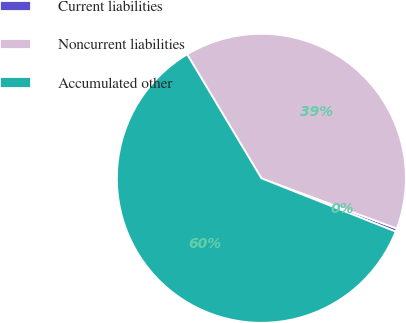Convert chart. <chart><loc_0><loc_0><loc_500><loc_500><pie_chart><fcel>Current liabilities<fcel>Noncurrent liabilities<fcel>Accumulated other<nl><fcel>0.36%<fcel>39.24%<fcel>60.4%<nl></chart> 